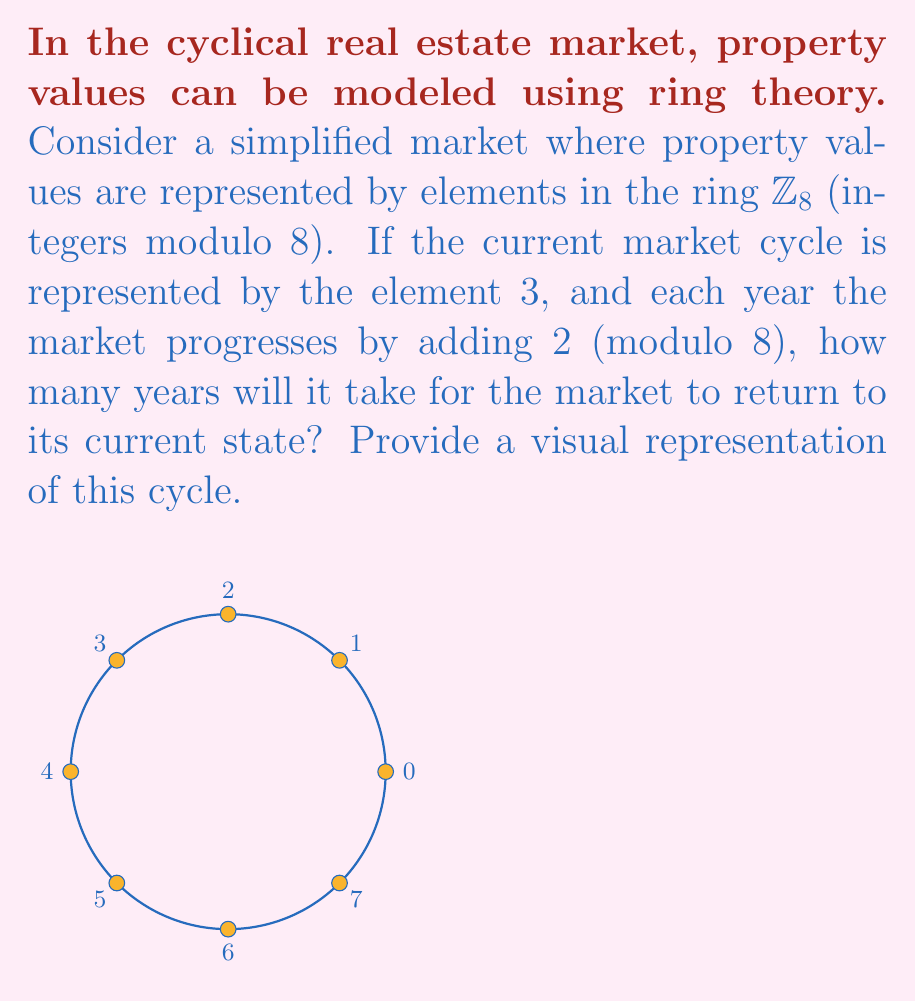Show me your answer to this math problem. Let's approach this step-by-step:

1) We start with the element $3$ in $\mathbb{Z}_8$.

2) Each year, we add $2$ modulo 8. Let's see how the cycle progresses:

   Year 0: $3$
   Year 1: $3 + 2 \equiv 5 \pmod{8}$
   Year 2: $5 + 2 \equiv 7 \pmod{8}$
   Year 3: $7 + 2 \equiv 1 \pmod{8}$
   Year 4: $1 + 2 \equiv 3 \pmod{8}$

3) We see that after 4 years, we return to the original state ($3$).

4) To verify this algebraically, we can use the properties of modular arithmetic:

   $3 + 2k \equiv 3 \pmod{8}$, where $k$ is the number of years.

   $2k \equiv 0 \pmod{8}$

   $k \equiv 0 \pmod{4}$

5) The smallest positive value of $k$ that satisfies this is 4.

This cycle can be visualized as rotating around the circle in the diagram by 90° (a quarter turn) each year, returning to the starting point after four rotations.
Answer: 4 years 